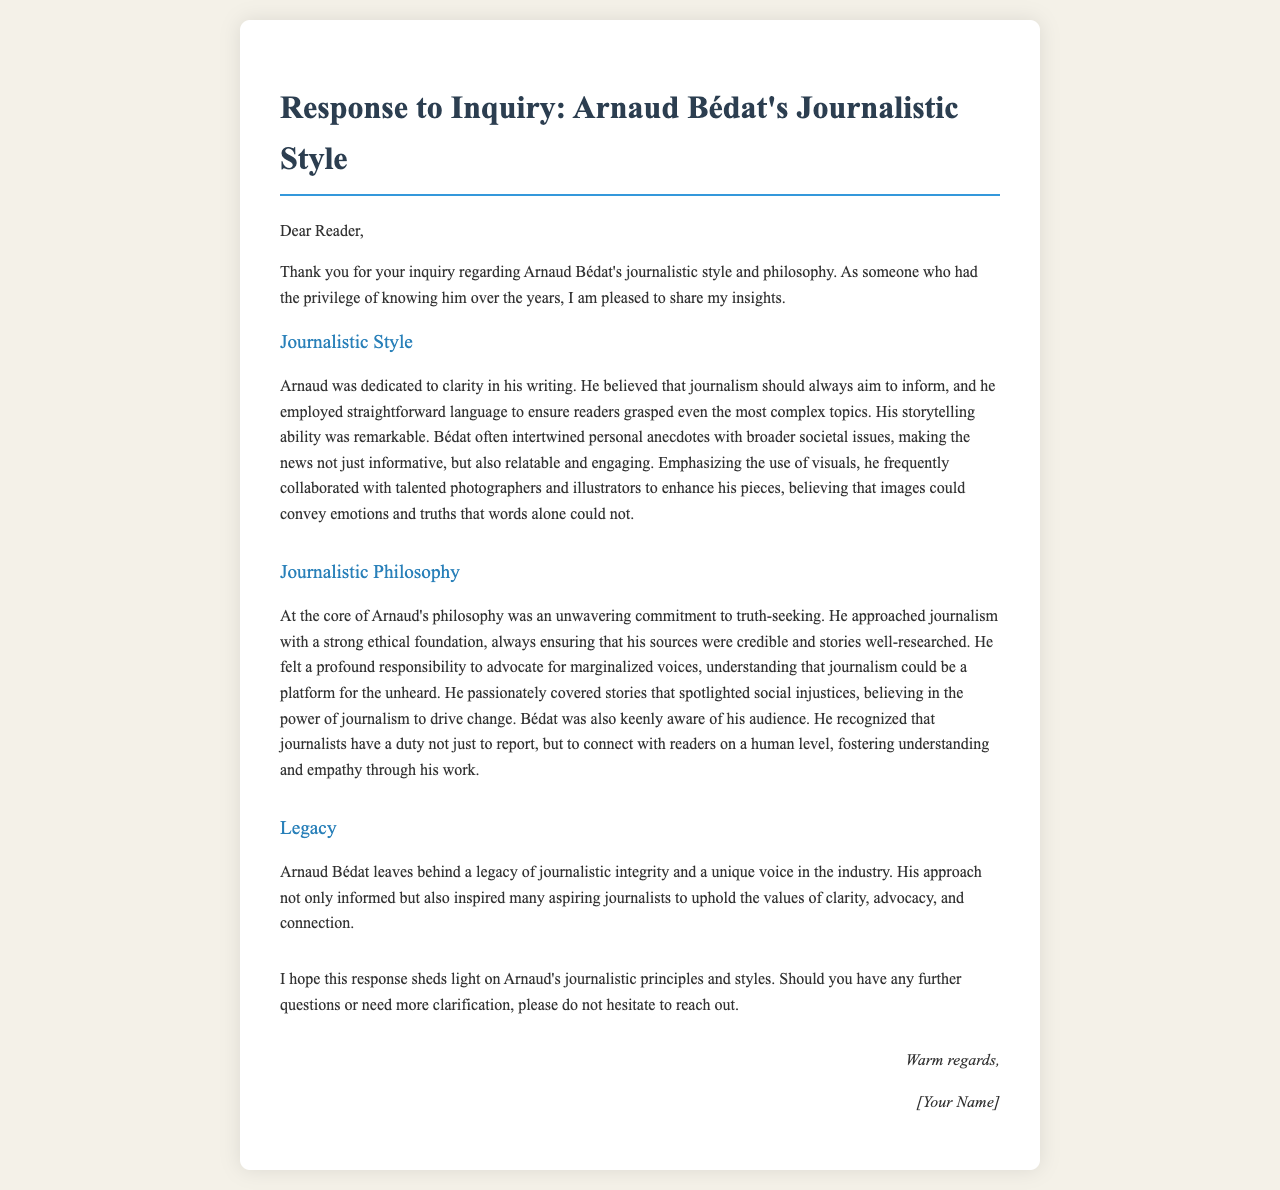What is Arnaud Bédat's commitment at the core of his philosophy? The document states that Arnaud's philosophy centers on an unwavering commitment to truth-seeking.
Answer: truth-seeking What is one visual element Arnaud Bédat emphasized in his work? He believed in the importance of collaborating with talented photographers and illustrators to enhance his pieces.
Answer: visuals What kind of stories did Bédat passionately cover? According to the document, he spotlighted stories that focused on social injustices.
Answer: social injustices How did Arnaud Bédat aim to inform his readers? The document highlights that he employed straightforward language to ensure readers grasped complex topics.
Answer: straightforward language What does the document list as part of Bédat's journalistic legacy? The document indicates that he leaves behind a legacy of journalistic integrity and a unique voice.
Answer: journalistic integrity What was a notable aspect of Arnaud Bédat's storytelling ability? He intertwined personal anecdotes with broader societal issues, making news relatable and engaging.
Answer: personal anecdotes What is the tone of the closing statement in the letter? The letter concludes with a warm and inviting tone, encouraging further inquiries.
Answer: warm regards What does Arnaud believe journalism can be a platform for? The document states he understood that journalism could be a platform for the unheard.
Answer: unheard 